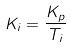Convert formula to latex. <formula><loc_0><loc_0><loc_500><loc_500>K _ { i } = \frac { K _ { p } } { T _ { i } }</formula> 